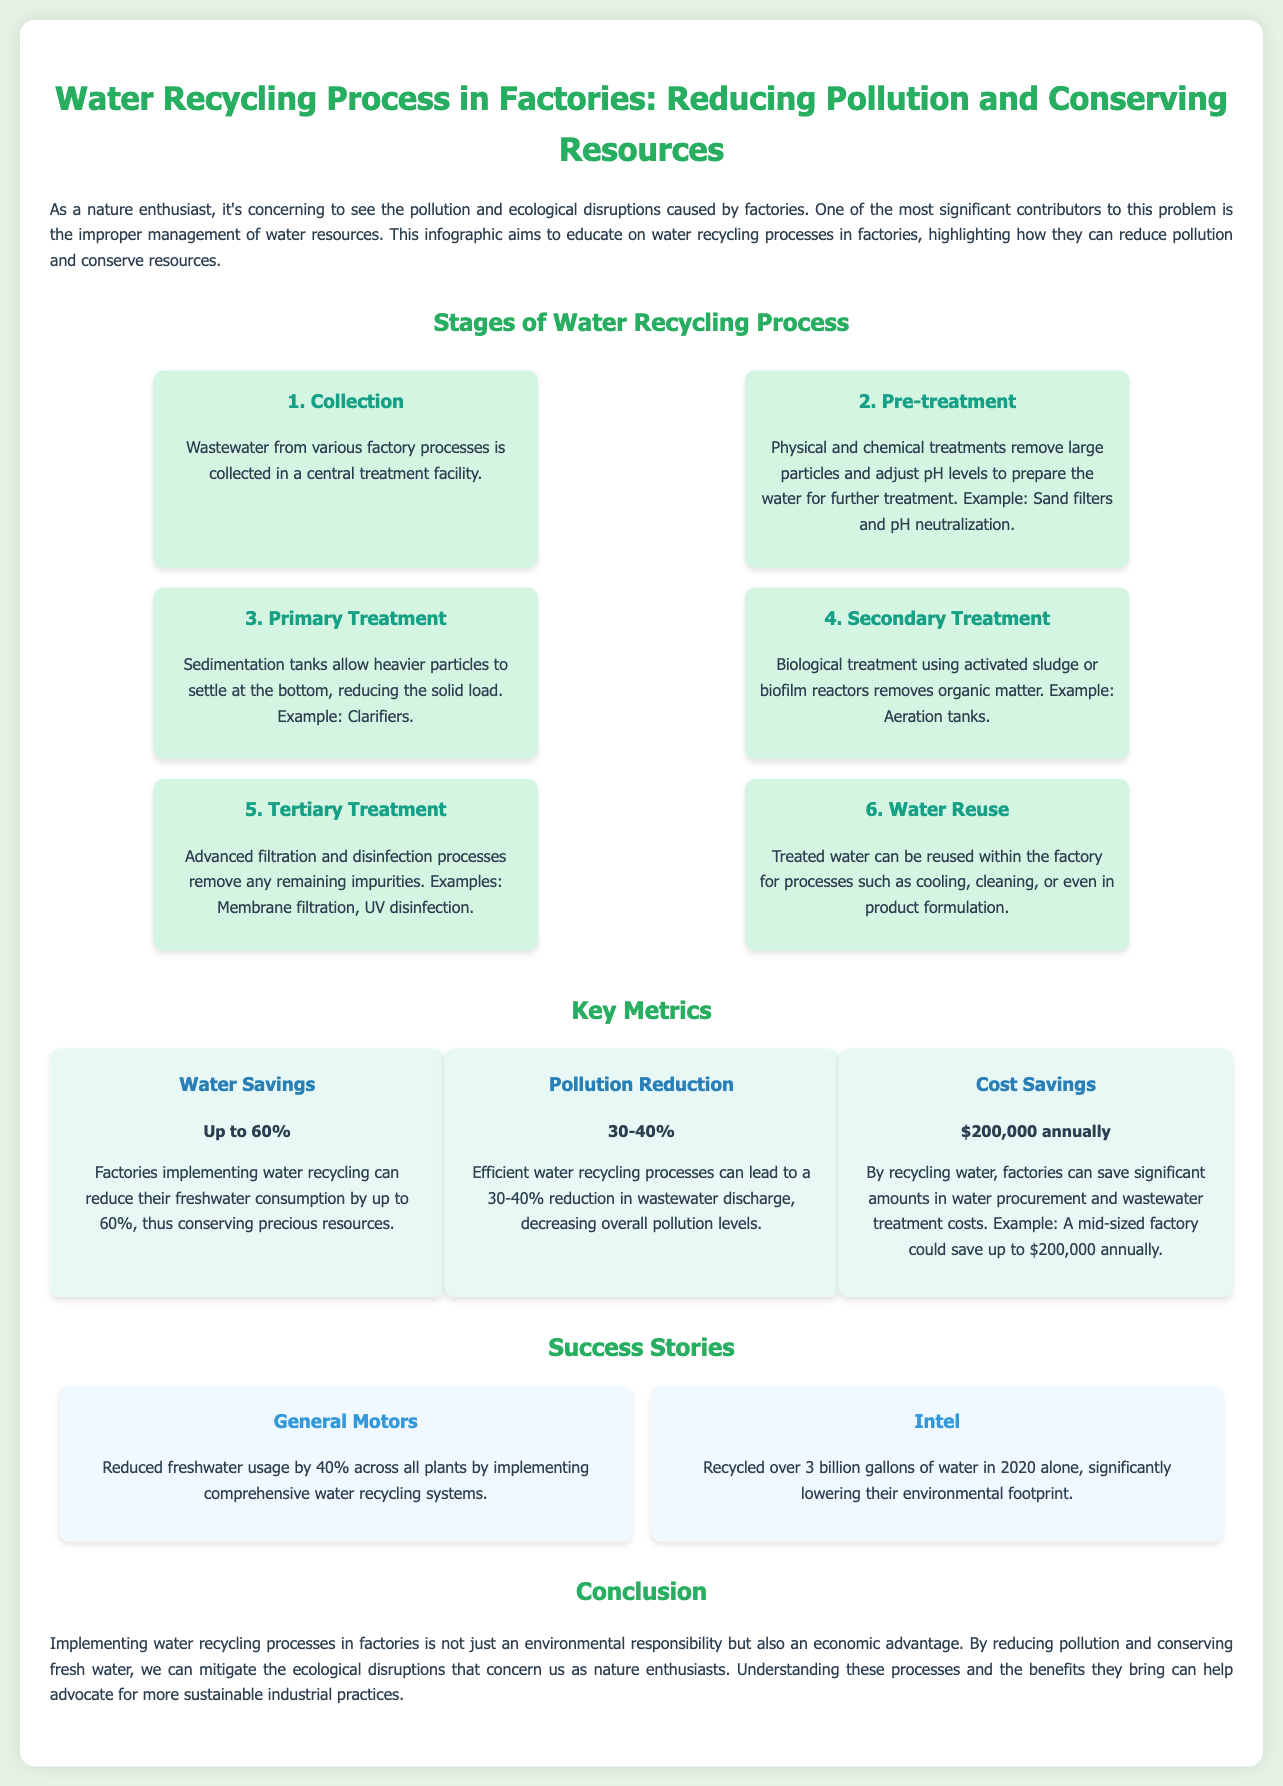What is the first stage of the water recycling process? The first stage is collection of wastewater in a central treatment facility.
Answer: Collection What percentage of freshwater can factories save by implementing water recycling? Factories can reduce freshwater consumption by up to 60%.
Answer: 60% What is the primary treatment stage focused on? The primary treatment focuses on reducing the solid load by allowing heavier particles to settle.
Answer: Sedimentation Which company recycled over 3 billion gallons of water in 2020? Intel is the company that recycled over 3 billion gallons of water in 2020.
Answer: Intel What type of treatment involves biological processes to remove organic matter? The secondary treatment involves biological processes.
Answer: Secondary Treatment How much can factories save annually by recycling water? A mid-sized factory could save up to $200,000 annually.
Answer: $200,000 What is the final step in the water recycling process? The final step is water reuse for various processes within the factory.
Answer: Water Reuse What advanced methods are used in tertiary treatment? Advanced filtration and disinfection processes are used in tertiary treatment.
Answer: Filtration and disinfection What environmental benefit is highlighted in the infographic? The infographic highlights pollution reduction as an environmental benefit.
Answer: Pollution Reduction 